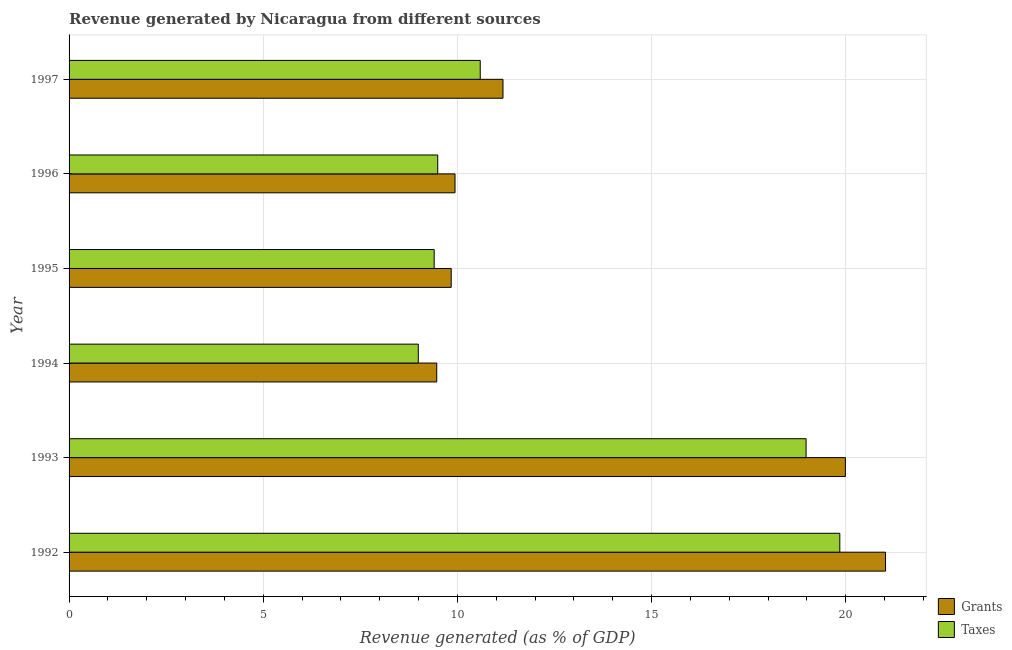How many different coloured bars are there?
Your response must be concise. 2. Are the number of bars per tick equal to the number of legend labels?
Offer a terse response. Yes. Are the number of bars on each tick of the Y-axis equal?
Keep it short and to the point. Yes. How many bars are there on the 5th tick from the top?
Offer a terse response. 2. In how many cases, is the number of bars for a given year not equal to the number of legend labels?
Offer a terse response. 0. What is the revenue generated by grants in 1997?
Your response must be concise. 11.17. Across all years, what is the maximum revenue generated by taxes?
Your answer should be very brief. 19.85. Across all years, what is the minimum revenue generated by taxes?
Give a very brief answer. 8.99. What is the total revenue generated by grants in the graph?
Give a very brief answer. 81.44. What is the difference between the revenue generated by grants in 1994 and that in 1995?
Your response must be concise. -0.37. What is the difference between the revenue generated by grants in 1992 and the revenue generated by taxes in 1994?
Make the answer very short. 12.03. What is the average revenue generated by grants per year?
Keep it short and to the point. 13.57. In the year 1996, what is the difference between the revenue generated by grants and revenue generated by taxes?
Your response must be concise. 0.45. In how many years, is the revenue generated by taxes greater than 10 %?
Give a very brief answer. 3. What is the ratio of the revenue generated by taxes in 1992 to that in 1995?
Offer a very short reply. 2.11. What is the difference between the highest and the second highest revenue generated by taxes?
Your answer should be very brief. 0.87. What is the difference between the highest and the lowest revenue generated by grants?
Keep it short and to the point. 11.56. In how many years, is the revenue generated by taxes greater than the average revenue generated by taxes taken over all years?
Offer a terse response. 2. Is the sum of the revenue generated by grants in 1993 and 1994 greater than the maximum revenue generated by taxes across all years?
Your answer should be very brief. Yes. What does the 1st bar from the top in 1995 represents?
Provide a short and direct response. Taxes. What does the 2nd bar from the bottom in 1996 represents?
Your answer should be very brief. Taxes. Are all the bars in the graph horizontal?
Provide a short and direct response. Yes. What is the difference between two consecutive major ticks on the X-axis?
Provide a short and direct response. 5. Are the values on the major ticks of X-axis written in scientific E-notation?
Offer a terse response. No. Does the graph contain any zero values?
Provide a short and direct response. No. Does the graph contain grids?
Your answer should be compact. Yes. Where does the legend appear in the graph?
Your answer should be very brief. Bottom right. What is the title of the graph?
Your response must be concise. Revenue generated by Nicaragua from different sources. Does "Food" appear as one of the legend labels in the graph?
Your answer should be compact. No. What is the label or title of the X-axis?
Keep it short and to the point. Revenue generated (as % of GDP). What is the label or title of the Y-axis?
Offer a very short reply. Year. What is the Revenue generated (as % of GDP) of Grants in 1992?
Keep it short and to the point. 21.03. What is the Revenue generated (as % of GDP) in Taxes in 1992?
Give a very brief answer. 19.85. What is the Revenue generated (as % of GDP) in Grants in 1993?
Ensure brevity in your answer.  19.99. What is the Revenue generated (as % of GDP) in Taxes in 1993?
Offer a terse response. 18.98. What is the Revenue generated (as % of GDP) in Grants in 1994?
Offer a very short reply. 9.47. What is the Revenue generated (as % of GDP) of Taxes in 1994?
Provide a succinct answer. 8.99. What is the Revenue generated (as % of GDP) in Grants in 1995?
Make the answer very short. 9.84. What is the Revenue generated (as % of GDP) in Taxes in 1995?
Your answer should be very brief. 9.4. What is the Revenue generated (as % of GDP) of Grants in 1996?
Provide a short and direct response. 9.94. What is the Revenue generated (as % of GDP) in Taxes in 1996?
Offer a terse response. 9.49. What is the Revenue generated (as % of GDP) in Grants in 1997?
Make the answer very short. 11.17. What is the Revenue generated (as % of GDP) of Taxes in 1997?
Provide a succinct answer. 10.59. Across all years, what is the maximum Revenue generated (as % of GDP) in Grants?
Give a very brief answer. 21.03. Across all years, what is the maximum Revenue generated (as % of GDP) in Taxes?
Provide a short and direct response. 19.85. Across all years, what is the minimum Revenue generated (as % of GDP) of Grants?
Provide a short and direct response. 9.47. Across all years, what is the minimum Revenue generated (as % of GDP) of Taxes?
Keep it short and to the point. 8.99. What is the total Revenue generated (as % of GDP) of Grants in the graph?
Give a very brief answer. 81.44. What is the total Revenue generated (as % of GDP) in Taxes in the graph?
Offer a terse response. 77.31. What is the difference between the Revenue generated (as % of GDP) of Grants in 1992 and that in 1993?
Provide a short and direct response. 1.03. What is the difference between the Revenue generated (as % of GDP) of Taxes in 1992 and that in 1993?
Provide a succinct answer. 0.87. What is the difference between the Revenue generated (as % of GDP) in Grants in 1992 and that in 1994?
Provide a short and direct response. 11.56. What is the difference between the Revenue generated (as % of GDP) of Taxes in 1992 and that in 1994?
Provide a succinct answer. 10.86. What is the difference between the Revenue generated (as % of GDP) of Grants in 1992 and that in 1995?
Ensure brevity in your answer.  11.19. What is the difference between the Revenue generated (as % of GDP) in Taxes in 1992 and that in 1995?
Provide a succinct answer. 10.45. What is the difference between the Revenue generated (as % of GDP) of Grants in 1992 and that in 1996?
Your response must be concise. 11.09. What is the difference between the Revenue generated (as % of GDP) of Taxes in 1992 and that in 1996?
Ensure brevity in your answer.  10.36. What is the difference between the Revenue generated (as % of GDP) of Grants in 1992 and that in 1997?
Provide a short and direct response. 9.85. What is the difference between the Revenue generated (as % of GDP) in Taxes in 1992 and that in 1997?
Ensure brevity in your answer.  9.26. What is the difference between the Revenue generated (as % of GDP) in Grants in 1993 and that in 1994?
Provide a short and direct response. 10.52. What is the difference between the Revenue generated (as % of GDP) in Taxes in 1993 and that in 1994?
Offer a very short reply. 9.99. What is the difference between the Revenue generated (as % of GDP) in Grants in 1993 and that in 1995?
Your answer should be very brief. 10.15. What is the difference between the Revenue generated (as % of GDP) in Taxes in 1993 and that in 1995?
Make the answer very short. 9.58. What is the difference between the Revenue generated (as % of GDP) of Grants in 1993 and that in 1996?
Make the answer very short. 10.05. What is the difference between the Revenue generated (as % of GDP) in Taxes in 1993 and that in 1996?
Give a very brief answer. 9.49. What is the difference between the Revenue generated (as % of GDP) in Grants in 1993 and that in 1997?
Your response must be concise. 8.82. What is the difference between the Revenue generated (as % of GDP) in Taxes in 1993 and that in 1997?
Your answer should be very brief. 8.39. What is the difference between the Revenue generated (as % of GDP) of Grants in 1994 and that in 1995?
Provide a short and direct response. -0.37. What is the difference between the Revenue generated (as % of GDP) of Taxes in 1994 and that in 1995?
Offer a very short reply. -0.41. What is the difference between the Revenue generated (as % of GDP) of Grants in 1994 and that in 1996?
Make the answer very short. -0.47. What is the difference between the Revenue generated (as % of GDP) in Taxes in 1994 and that in 1996?
Your answer should be very brief. -0.5. What is the difference between the Revenue generated (as % of GDP) of Grants in 1994 and that in 1997?
Your answer should be compact. -1.71. What is the difference between the Revenue generated (as % of GDP) in Taxes in 1994 and that in 1997?
Your response must be concise. -1.6. What is the difference between the Revenue generated (as % of GDP) of Grants in 1995 and that in 1996?
Your answer should be very brief. -0.1. What is the difference between the Revenue generated (as % of GDP) in Taxes in 1995 and that in 1996?
Give a very brief answer. -0.09. What is the difference between the Revenue generated (as % of GDP) in Grants in 1995 and that in 1997?
Your answer should be very brief. -1.33. What is the difference between the Revenue generated (as % of GDP) of Taxes in 1995 and that in 1997?
Ensure brevity in your answer.  -1.19. What is the difference between the Revenue generated (as % of GDP) of Grants in 1996 and that in 1997?
Offer a very short reply. -1.24. What is the difference between the Revenue generated (as % of GDP) in Taxes in 1996 and that in 1997?
Your answer should be very brief. -1.09. What is the difference between the Revenue generated (as % of GDP) of Grants in 1992 and the Revenue generated (as % of GDP) of Taxes in 1993?
Make the answer very short. 2.05. What is the difference between the Revenue generated (as % of GDP) in Grants in 1992 and the Revenue generated (as % of GDP) in Taxes in 1994?
Give a very brief answer. 12.03. What is the difference between the Revenue generated (as % of GDP) in Grants in 1992 and the Revenue generated (as % of GDP) in Taxes in 1995?
Your answer should be very brief. 11.62. What is the difference between the Revenue generated (as % of GDP) in Grants in 1992 and the Revenue generated (as % of GDP) in Taxes in 1996?
Offer a very short reply. 11.53. What is the difference between the Revenue generated (as % of GDP) in Grants in 1992 and the Revenue generated (as % of GDP) in Taxes in 1997?
Provide a succinct answer. 10.44. What is the difference between the Revenue generated (as % of GDP) of Grants in 1993 and the Revenue generated (as % of GDP) of Taxes in 1994?
Offer a terse response. 11. What is the difference between the Revenue generated (as % of GDP) of Grants in 1993 and the Revenue generated (as % of GDP) of Taxes in 1995?
Provide a succinct answer. 10.59. What is the difference between the Revenue generated (as % of GDP) in Grants in 1993 and the Revenue generated (as % of GDP) in Taxes in 1996?
Offer a terse response. 10.5. What is the difference between the Revenue generated (as % of GDP) in Grants in 1993 and the Revenue generated (as % of GDP) in Taxes in 1997?
Your response must be concise. 9.4. What is the difference between the Revenue generated (as % of GDP) of Grants in 1994 and the Revenue generated (as % of GDP) of Taxes in 1995?
Ensure brevity in your answer.  0.07. What is the difference between the Revenue generated (as % of GDP) of Grants in 1994 and the Revenue generated (as % of GDP) of Taxes in 1996?
Offer a very short reply. -0.03. What is the difference between the Revenue generated (as % of GDP) in Grants in 1994 and the Revenue generated (as % of GDP) in Taxes in 1997?
Your answer should be compact. -1.12. What is the difference between the Revenue generated (as % of GDP) of Grants in 1995 and the Revenue generated (as % of GDP) of Taxes in 1996?
Provide a short and direct response. 0.35. What is the difference between the Revenue generated (as % of GDP) in Grants in 1995 and the Revenue generated (as % of GDP) in Taxes in 1997?
Offer a terse response. -0.75. What is the difference between the Revenue generated (as % of GDP) of Grants in 1996 and the Revenue generated (as % of GDP) of Taxes in 1997?
Offer a terse response. -0.65. What is the average Revenue generated (as % of GDP) of Grants per year?
Your answer should be compact. 13.57. What is the average Revenue generated (as % of GDP) of Taxes per year?
Give a very brief answer. 12.89. In the year 1992, what is the difference between the Revenue generated (as % of GDP) in Grants and Revenue generated (as % of GDP) in Taxes?
Provide a succinct answer. 1.18. In the year 1993, what is the difference between the Revenue generated (as % of GDP) of Grants and Revenue generated (as % of GDP) of Taxes?
Give a very brief answer. 1.01. In the year 1994, what is the difference between the Revenue generated (as % of GDP) in Grants and Revenue generated (as % of GDP) in Taxes?
Your answer should be very brief. 0.47. In the year 1995, what is the difference between the Revenue generated (as % of GDP) in Grants and Revenue generated (as % of GDP) in Taxes?
Your answer should be very brief. 0.44. In the year 1996, what is the difference between the Revenue generated (as % of GDP) of Grants and Revenue generated (as % of GDP) of Taxes?
Your response must be concise. 0.45. In the year 1997, what is the difference between the Revenue generated (as % of GDP) of Grants and Revenue generated (as % of GDP) of Taxes?
Ensure brevity in your answer.  0.59. What is the ratio of the Revenue generated (as % of GDP) of Grants in 1992 to that in 1993?
Make the answer very short. 1.05. What is the ratio of the Revenue generated (as % of GDP) in Taxes in 1992 to that in 1993?
Keep it short and to the point. 1.05. What is the ratio of the Revenue generated (as % of GDP) in Grants in 1992 to that in 1994?
Your answer should be compact. 2.22. What is the ratio of the Revenue generated (as % of GDP) in Taxes in 1992 to that in 1994?
Your answer should be compact. 2.21. What is the ratio of the Revenue generated (as % of GDP) of Grants in 1992 to that in 1995?
Your response must be concise. 2.14. What is the ratio of the Revenue generated (as % of GDP) of Taxes in 1992 to that in 1995?
Provide a short and direct response. 2.11. What is the ratio of the Revenue generated (as % of GDP) of Grants in 1992 to that in 1996?
Ensure brevity in your answer.  2.12. What is the ratio of the Revenue generated (as % of GDP) in Taxes in 1992 to that in 1996?
Provide a succinct answer. 2.09. What is the ratio of the Revenue generated (as % of GDP) in Grants in 1992 to that in 1997?
Your answer should be compact. 1.88. What is the ratio of the Revenue generated (as % of GDP) of Taxes in 1992 to that in 1997?
Provide a succinct answer. 1.87. What is the ratio of the Revenue generated (as % of GDP) in Grants in 1993 to that in 1994?
Your answer should be very brief. 2.11. What is the ratio of the Revenue generated (as % of GDP) of Taxes in 1993 to that in 1994?
Offer a terse response. 2.11. What is the ratio of the Revenue generated (as % of GDP) of Grants in 1993 to that in 1995?
Your response must be concise. 2.03. What is the ratio of the Revenue generated (as % of GDP) of Taxes in 1993 to that in 1995?
Provide a short and direct response. 2.02. What is the ratio of the Revenue generated (as % of GDP) of Grants in 1993 to that in 1996?
Your answer should be very brief. 2.01. What is the ratio of the Revenue generated (as % of GDP) of Taxes in 1993 to that in 1996?
Keep it short and to the point. 2. What is the ratio of the Revenue generated (as % of GDP) of Grants in 1993 to that in 1997?
Provide a short and direct response. 1.79. What is the ratio of the Revenue generated (as % of GDP) in Taxes in 1993 to that in 1997?
Make the answer very short. 1.79. What is the ratio of the Revenue generated (as % of GDP) in Grants in 1994 to that in 1995?
Keep it short and to the point. 0.96. What is the ratio of the Revenue generated (as % of GDP) in Taxes in 1994 to that in 1995?
Your response must be concise. 0.96. What is the ratio of the Revenue generated (as % of GDP) in Grants in 1994 to that in 1996?
Your response must be concise. 0.95. What is the ratio of the Revenue generated (as % of GDP) of Taxes in 1994 to that in 1996?
Ensure brevity in your answer.  0.95. What is the ratio of the Revenue generated (as % of GDP) in Grants in 1994 to that in 1997?
Your answer should be very brief. 0.85. What is the ratio of the Revenue generated (as % of GDP) in Taxes in 1994 to that in 1997?
Keep it short and to the point. 0.85. What is the ratio of the Revenue generated (as % of GDP) in Grants in 1995 to that in 1996?
Your answer should be compact. 0.99. What is the ratio of the Revenue generated (as % of GDP) of Taxes in 1995 to that in 1996?
Offer a terse response. 0.99. What is the ratio of the Revenue generated (as % of GDP) of Grants in 1995 to that in 1997?
Provide a succinct answer. 0.88. What is the ratio of the Revenue generated (as % of GDP) of Taxes in 1995 to that in 1997?
Your answer should be very brief. 0.89. What is the ratio of the Revenue generated (as % of GDP) of Grants in 1996 to that in 1997?
Offer a terse response. 0.89. What is the ratio of the Revenue generated (as % of GDP) in Taxes in 1996 to that in 1997?
Keep it short and to the point. 0.9. What is the difference between the highest and the second highest Revenue generated (as % of GDP) of Grants?
Keep it short and to the point. 1.03. What is the difference between the highest and the second highest Revenue generated (as % of GDP) of Taxes?
Your answer should be very brief. 0.87. What is the difference between the highest and the lowest Revenue generated (as % of GDP) in Grants?
Make the answer very short. 11.56. What is the difference between the highest and the lowest Revenue generated (as % of GDP) of Taxes?
Keep it short and to the point. 10.86. 